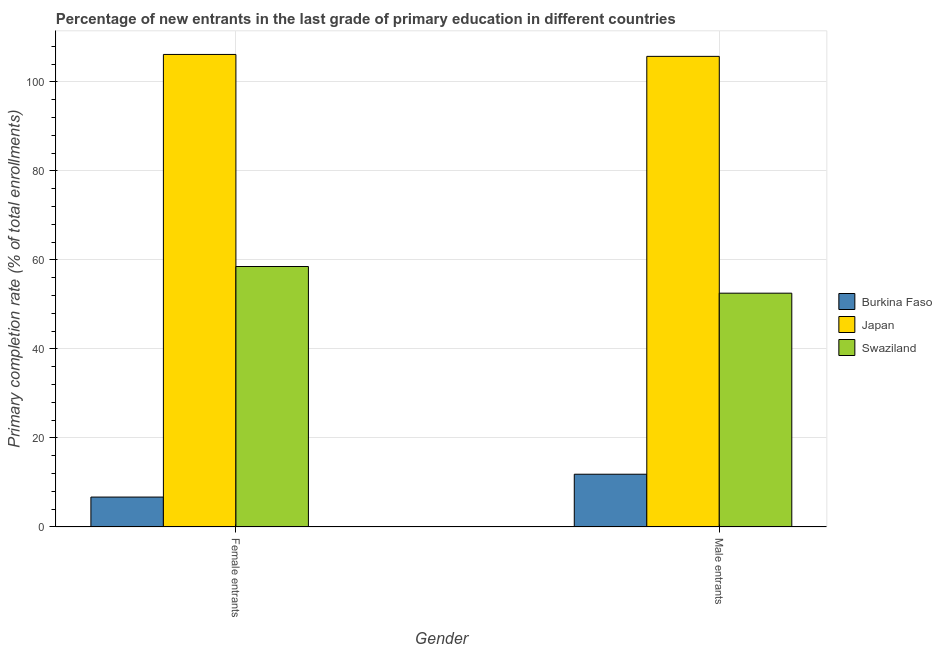How many bars are there on the 2nd tick from the left?
Provide a succinct answer. 3. How many bars are there on the 2nd tick from the right?
Give a very brief answer. 3. What is the label of the 1st group of bars from the left?
Keep it short and to the point. Female entrants. What is the primary completion rate of male entrants in Swaziland?
Offer a very short reply. 52.52. Across all countries, what is the maximum primary completion rate of male entrants?
Keep it short and to the point. 105.72. Across all countries, what is the minimum primary completion rate of female entrants?
Keep it short and to the point. 6.72. In which country was the primary completion rate of male entrants maximum?
Offer a terse response. Japan. In which country was the primary completion rate of male entrants minimum?
Offer a terse response. Burkina Faso. What is the total primary completion rate of female entrants in the graph?
Ensure brevity in your answer.  171.39. What is the difference between the primary completion rate of female entrants in Burkina Faso and that in Japan?
Keep it short and to the point. -99.43. What is the difference between the primary completion rate of female entrants in Burkina Faso and the primary completion rate of male entrants in Japan?
Provide a short and direct response. -99. What is the average primary completion rate of male entrants per country?
Give a very brief answer. 56.7. What is the difference between the primary completion rate of male entrants and primary completion rate of female entrants in Burkina Faso?
Give a very brief answer. 5.13. What is the ratio of the primary completion rate of male entrants in Swaziland to that in Burkina Faso?
Your response must be concise. 4.43. What does the 3rd bar from the left in Female entrants represents?
Ensure brevity in your answer.  Swaziland. What does the 2nd bar from the right in Female entrants represents?
Your response must be concise. Japan. How many bars are there?
Your response must be concise. 6. Are all the bars in the graph horizontal?
Your response must be concise. No. Does the graph contain any zero values?
Offer a terse response. No. How many legend labels are there?
Ensure brevity in your answer.  3. How are the legend labels stacked?
Your answer should be compact. Vertical. What is the title of the graph?
Make the answer very short. Percentage of new entrants in the last grade of primary education in different countries. What is the label or title of the X-axis?
Offer a terse response. Gender. What is the label or title of the Y-axis?
Provide a succinct answer. Primary completion rate (% of total enrollments). What is the Primary completion rate (% of total enrollments) in Burkina Faso in Female entrants?
Provide a succinct answer. 6.72. What is the Primary completion rate (% of total enrollments) in Japan in Female entrants?
Your response must be concise. 106.15. What is the Primary completion rate (% of total enrollments) in Swaziland in Female entrants?
Make the answer very short. 58.52. What is the Primary completion rate (% of total enrollments) of Burkina Faso in Male entrants?
Offer a terse response. 11.85. What is the Primary completion rate (% of total enrollments) of Japan in Male entrants?
Your response must be concise. 105.72. What is the Primary completion rate (% of total enrollments) of Swaziland in Male entrants?
Keep it short and to the point. 52.52. Across all Gender, what is the maximum Primary completion rate (% of total enrollments) of Burkina Faso?
Your answer should be very brief. 11.85. Across all Gender, what is the maximum Primary completion rate (% of total enrollments) of Japan?
Offer a terse response. 106.15. Across all Gender, what is the maximum Primary completion rate (% of total enrollments) of Swaziland?
Your response must be concise. 58.52. Across all Gender, what is the minimum Primary completion rate (% of total enrollments) of Burkina Faso?
Ensure brevity in your answer.  6.72. Across all Gender, what is the minimum Primary completion rate (% of total enrollments) in Japan?
Make the answer very short. 105.72. Across all Gender, what is the minimum Primary completion rate (% of total enrollments) in Swaziland?
Your answer should be very brief. 52.52. What is the total Primary completion rate (% of total enrollments) in Burkina Faso in the graph?
Your response must be concise. 18.58. What is the total Primary completion rate (% of total enrollments) in Japan in the graph?
Offer a very short reply. 211.87. What is the total Primary completion rate (% of total enrollments) of Swaziland in the graph?
Your answer should be very brief. 111.04. What is the difference between the Primary completion rate (% of total enrollments) of Burkina Faso in Female entrants and that in Male entrants?
Your answer should be very brief. -5.13. What is the difference between the Primary completion rate (% of total enrollments) in Japan in Female entrants and that in Male entrants?
Offer a terse response. 0.43. What is the difference between the Primary completion rate (% of total enrollments) in Swaziland in Female entrants and that in Male entrants?
Give a very brief answer. 5.99. What is the difference between the Primary completion rate (% of total enrollments) of Burkina Faso in Female entrants and the Primary completion rate (% of total enrollments) of Japan in Male entrants?
Offer a very short reply. -99. What is the difference between the Primary completion rate (% of total enrollments) in Burkina Faso in Female entrants and the Primary completion rate (% of total enrollments) in Swaziland in Male entrants?
Offer a very short reply. -45.8. What is the difference between the Primary completion rate (% of total enrollments) in Japan in Female entrants and the Primary completion rate (% of total enrollments) in Swaziland in Male entrants?
Your answer should be very brief. 53.63. What is the average Primary completion rate (% of total enrollments) in Burkina Faso per Gender?
Offer a terse response. 9.29. What is the average Primary completion rate (% of total enrollments) of Japan per Gender?
Provide a succinct answer. 105.94. What is the average Primary completion rate (% of total enrollments) in Swaziland per Gender?
Offer a terse response. 55.52. What is the difference between the Primary completion rate (% of total enrollments) in Burkina Faso and Primary completion rate (% of total enrollments) in Japan in Female entrants?
Provide a short and direct response. -99.43. What is the difference between the Primary completion rate (% of total enrollments) of Burkina Faso and Primary completion rate (% of total enrollments) of Swaziland in Female entrants?
Keep it short and to the point. -51.79. What is the difference between the Primary completion rate (% of total enrollments) in Japan and Primary completion rate (% of total enrollments) in Swaziland in Female entrants?
Your answer should be very brief. 47.64. What is the difference between the Primary completion rate (% of total enrollments) in Burkina Faso and Primary completion rate (% of total enrollments) in Japan in Male entrants?
Ensure brevity in your answer.  -93.87. What is the difference between the Primary completion rate (% of total enrollments) in Burkina Faso and Primary completion rate (% of total enrollments) in Swaziland in Male entrants?
Give a very brief answer. -40.67. What is the difference between the Primary completion rate (% of total enrollments) of Japan and Primary completion rate (% of total enrollments) of Swaziland in Male entrants?
Ensure brevity in your answer.  53.2. What is the ratio of the Primary completion rate (% of total enrollments) in Burkina Faso in Female entrants to that in Male entrants?
Your answer should be very brief. 0.57. What is the ratio of the Primary completion rate (% of total enrollments) of Japan in Female entrants to that in Male entrants?
Offer a terse response. 1. What is the ratio of the Primary completion rate (% of total enrollments) of Swaziland in Female entrants to that in Male entrants?
Provide a succinct answer. 1.11. What is the difference between the highest and the second highest Primary completion rate (% of total enrollments) in Burkina Faso?
Provide a succinct answer. 5.13. What is the difference between the highest and the second highest Primary completion rate (% of total enrollments) in Japan?
Give a very brief answer. 0.43. What is the difference between the highest and the second highest Primary completion rate (% of total enrollments) in Swaziland?
Offer a terse response. 5.99. What is the difference between the highest and the lowest Primary completion rate (% of total enrollments) in Burkina Faso?
Offer a very short reply. 5.13. What is the difference between the highest and the lowest Primary completion rate (% of total enrollments) in Japan?
Provide a succinct answer. 0.43. What is the difference between the highest and the lowest Primary completion rate (% of total enrollments) of Swaziland?
Offer a very short reply. 5.99. 